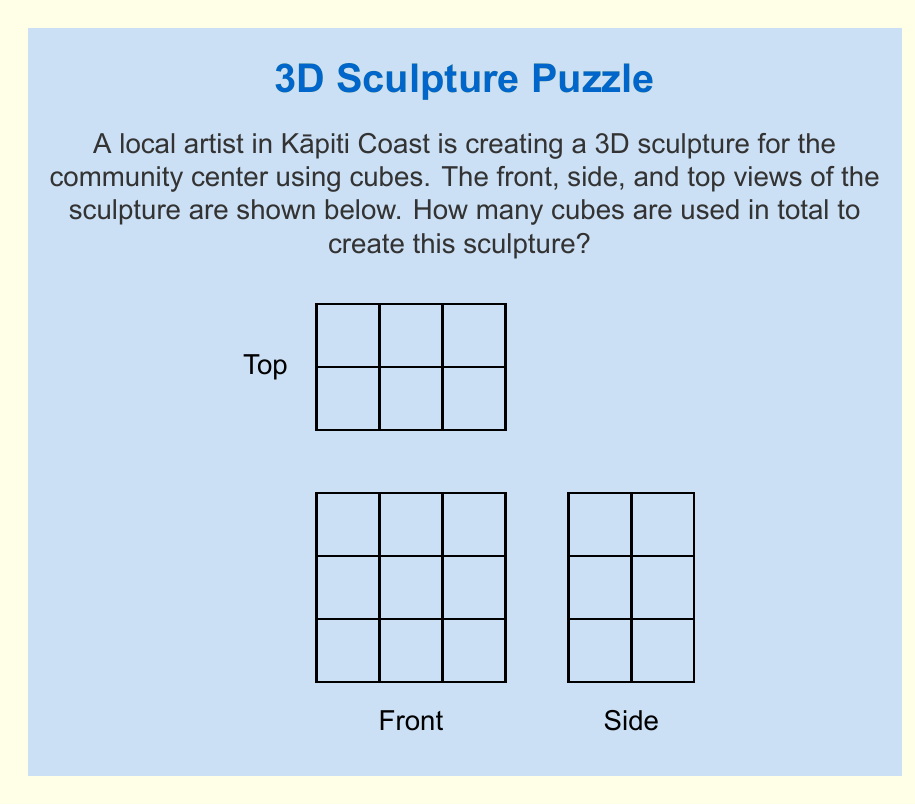Solve this math problem. To determine the total number of cubes in the 3D structure, we need to analyze the three given views:

1. Front view: 
   - Shows a 3x3 grid
   - Each cell represents at least one cube

2. Side view:
   - Shows a 2x3 grid
   - Indicates the depth of the structure is 2 cubes

3. Top view:
   - Shows a 3x2 grid
   - Confirms the width is 3 and depth is 2

Now, let's count the cubes layer by layer:

Layer 1 (bottom):
- From the front view, we see 3 cubes in the bottom row
- The side view shows this extends 2 cubes deep
- So, the bottom layer has 3 x 2 = 6 cubes

Layer 2 (middle):
- The front view shows 3 cubes in the middle row
- The side view confirms this extends 2 cubes deep
- The middle layer also has 3 x 2 = 6 cubes

Layer 3 (top):
- The front view shows 3 cubes in the top row
- However, the side view shows only 1 cube in the back for the top layer
- So the top layer has 3 x 1 = 3 cubes

Total number of cubes:
$$ \text{Total} = \text{Layer 1} + \text{Layer 2} + \text{Layer 3} $$
$$ \text{Total} = 6 + 6 + 3 = 15 $$

Therefore, the sculpture contains 15 cubes in total.
Answer: 15 cubes 